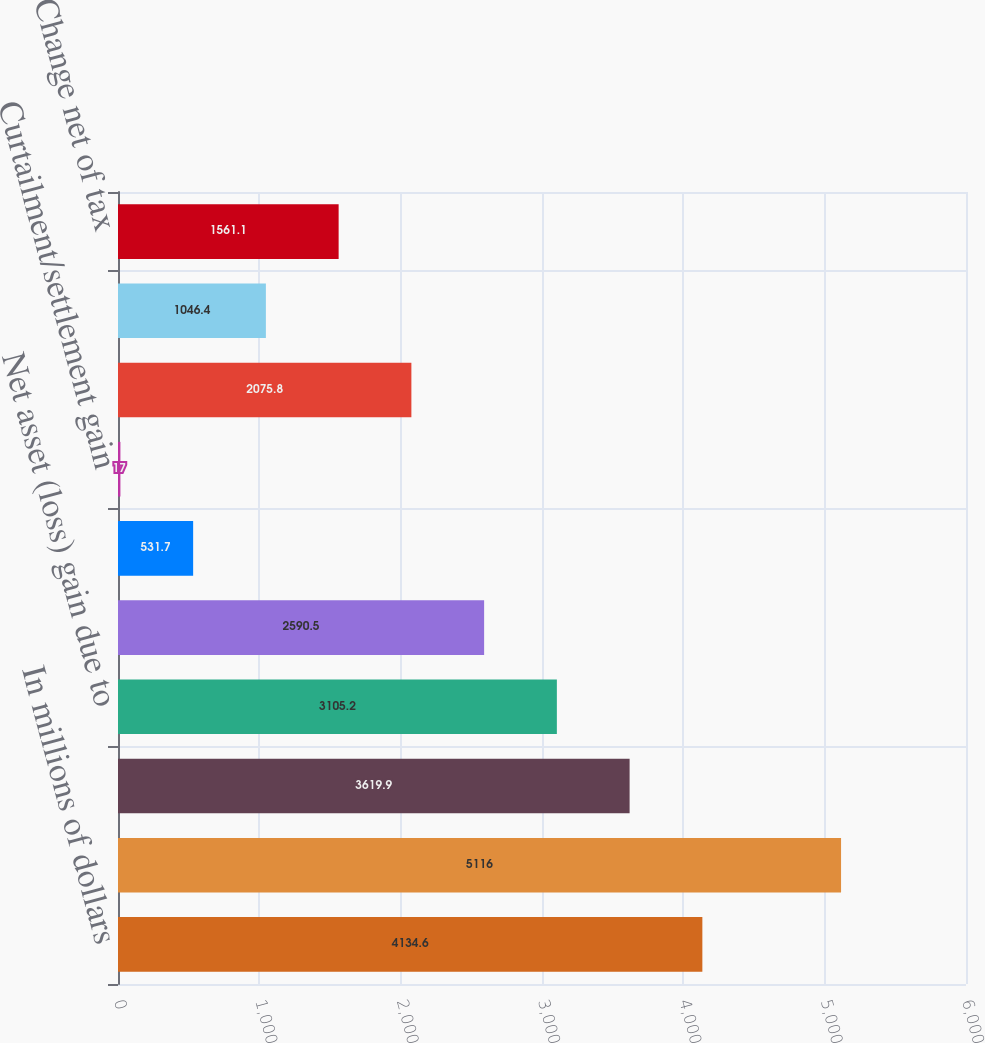<chart> <loc_0><loc_0><loc_500><loc_500><bar_chart><fcel>In millions of dollars<fcel>Beginning of year balance net<fcel>Actuarial assumptions changes<fcel>Net asset (loss) gain due to<fcel>Net amortization<fcel>Prior service (cost) credit<fcel>Curtailment/settlement gain<fcel>Foreign exchange impact and<fcel>Change in deferred taxes net<fcel>Change net of tax<nl><fcel>4134.6<fcel>5116<fcel>3619.9<fcel>3105.2<fcel>2590.5<fcel>531.7<fcel>17<fcel>2075.8<fcel>1046.4<fcel>1561.1<nl></chart> 